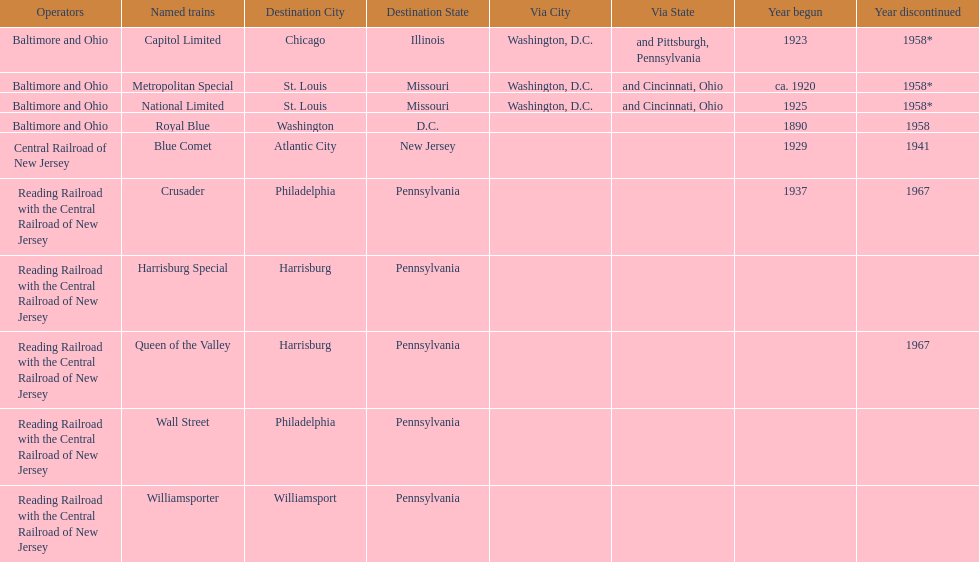Which other traine, other than wall street, had philadelphia as a destination? Crusader. 